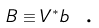<formula> <loc_0><loc_0><loc_500><loc_500>B \equiv V ^ { * } b \text { .}</formula> 